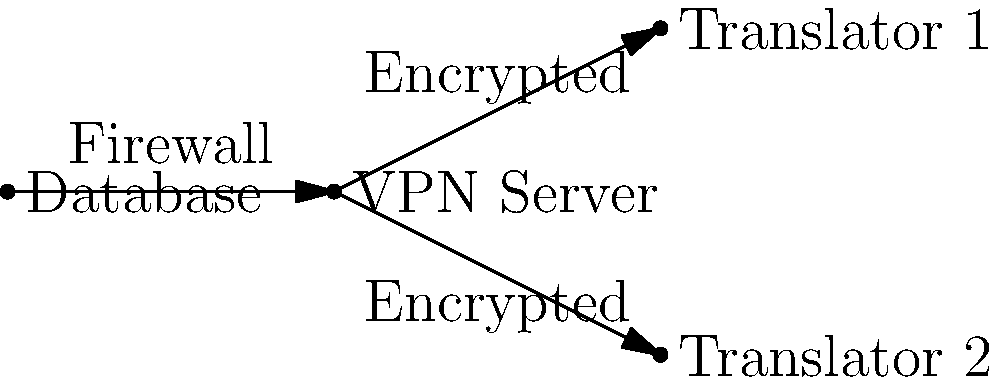In the network diagram shown, which component should be placed between the central book database and the VPN server to enhance security for remote translators accessing the database? To enhance security for remote translators accessing the central book database, we need to consider the following steps:

1. Identify the components: We have a central book database, a VPN server, and remote translators.

2. Understand the data flow: The remote translators need to access the database through the VPN server.

3. Recognize the security risk: Direct access from the VPN server to the database could be vulnerable to attacks.

4. Implement a security measure: A firewall should be placed between the database and the VPN server.

5. Function of the firewall:
   a) It filters incoming and outgoing traffic.
   b) It can be configured to allow only specific types of connections.
   c) It adds an extra layer of protection against unauthorized access.

6. VPN's role: The VPN ensures that the connection between the remote translators and the VPN server is encrypted and secure.

7. Complete security setup: The firewall protects the database, while the VPN secures the connection for remote translators.
Answer: Firewall 